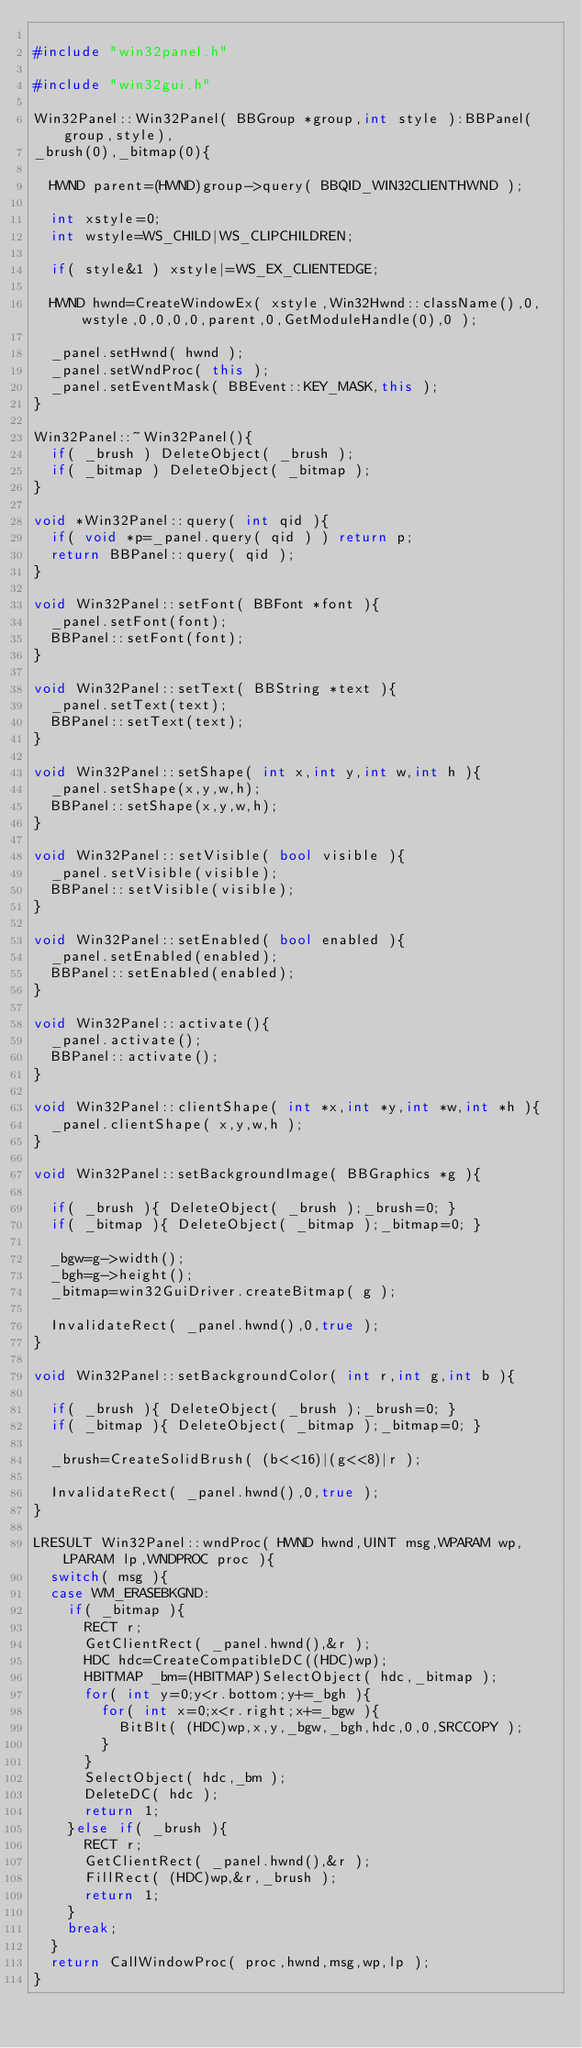<code> <loc_0><loc_0><loc_500><loc_500><_C++_>
#include "win32panel.h"

#include "win32gui.h"

Win32Panel::Win32Panel( BBGroup *group,int style ):BBPanel(group,style),
_brush(0),_bitmap(0){

	HWND parent=(HWND)group->query( BBQID_WIN32CLIENTHWND );

	int xstyle=0;
	int wstyle=WS_CHILD|WS_CLIPCHILDREN;

	if( style&1 ) xstyle|=WS_EX_CLIENTEDGE;

	HWND hwnd=CreateWindowEx( xstyle,Win32Hwnd::className(),0,wstyle,0,0,0,0,parent,0,GetModuleHandle(0),0 );

	_panel.setHwnd( hwnd );
	_panel.setWndProc( this );
	_panel.setEventMask( BBEvent::KEY_MASK,this );
}

Win32Panel::~Win32Panel(){
	if( _brush ) DeleteObject( _brush );
	if( _bitmap ) DeleteObject( _bitmap );
}

void *Win32Panel::query( int qid ){
	if( void *p=_panel.query( qid ) ) return p;
	return BBPanel::query( qid );
}

void Win32Panel::setFont( BBFont *font ){
	_panel.setFont(font);
	BBPanel::setFont(font);
}

void Win32Panel::setText( BBString *text ){
	_panel.setText(text);
	BBPanel::setText(text);
}

void Win32Panel::setShape( int x,int y,int w,int h ){
	_panel.setShape(x,y,w,h);
	BBPanel::setShape(x,y,w,h); 
}

void Win32Panel::setVisible( bool visible ){
	_panel.setVisible(visible);
	BBPanel::setVisible(visible);
}

void Win32Panel::setEnabled( bool enabled ){
	_panel.setEnabled(enabled);
	BBPanel::setEnabled(enabled);
}

void Win32Panel::activate(){
	_panel.activate();
	BBPanel::activate();
}

void Win32Panel::clientShape( int *x,int *y,int *w,int *h ){
	_panel.clientShape( x,y,w,h );
}

void Win32Panel::setBackgroundImage( BBGraphics *g ){

	if( _brush ){ DeleteObject( _brush );_brush=0; }
	if( _bitmap ){ DeleteObject( _bitmap );_bitmap=0; }

	_bgw=g->width();
	_bgh=g->height();
	_bitmap=win32GuiDriver.createBitmap( g );

	InvalidateRect( _panel.hwnd(),0,true );
}

void Win32Panel::setBackgroundColor( int r,int g,int b ){

	if( _brush ){ DeleteObject( _brush );_brush=0; }
	if( _bitmap ){ DeleteObject( _bitmap );_bitmap=0; }

	_brush=CreateSolidBrush( (b<<16)|(g<<8)|r );

	InvalidateRect( _panel.hwnd(),0,true );
}

LRESULT Win32Panel::wndProc( HWND hwnd,UINT msg,WPARAM wp,LPARAM lp,WNDPROC proc ){
	switch( msg ){
	case WM_ERASEBKGND:
		if( _bitmap ){
			RECT r;
			GetClientRect( _panel.hwnd(),&r );
			HDC hdc=CreateCompatibleDC((HDC)wp);
			HBITMAP _bm=(HBITMAP)SelectObject( hdc,_bitmap );
			for( int y=0;y<r.bottom;y+=_bgh ){
				for( int x=0;x<r.right;x+=_bgw ){
					BitBlt( (HDC)wp,x,y,_bgw,_bgh,hdc,0,0,SRCCOPY );
				}
			}
			SelectObject( hdc,_bm );
			DeleteDC( hdc );
			return 1;
		}else if( _brush ){
			RECT r;
			GetClientRect( _panel.hwnd(),&r );
			FillRect( (HDC)wp,&r,_brush );
			return 1;
		}
		break;
	}
	return CallWindowProc( proc,hwnd,msg,wp,lp );
}
</code> 